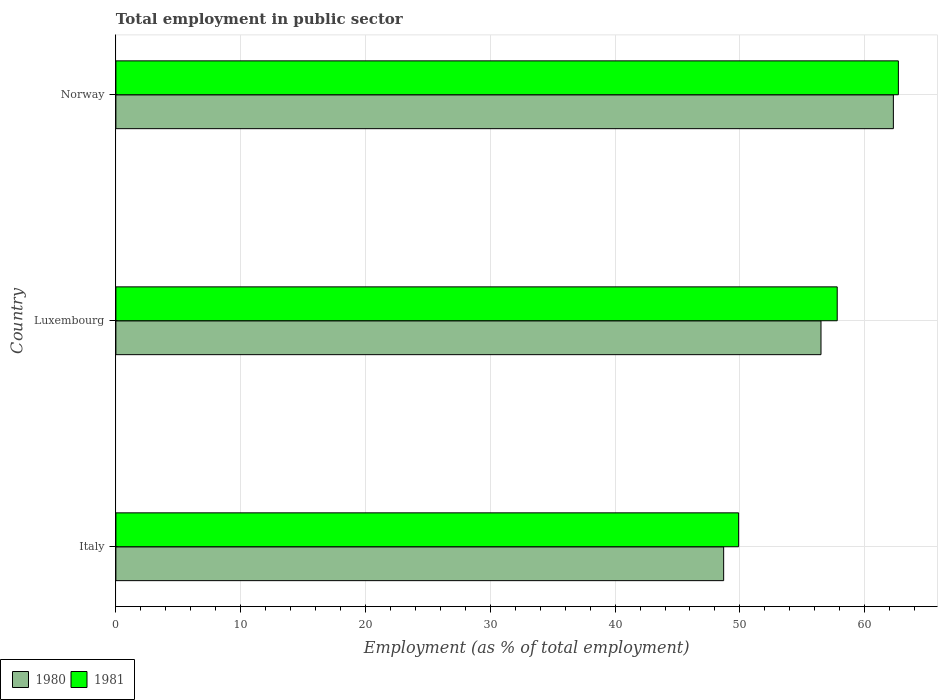Are the number of bars on each tick of the Y-axis equal?
Your answer should be very brief. Yes. How many bars are there on the 3rd tick from the bottom?
Your response must be concise. 2. What is the employment in public sector in 1981 in Luxembourg?
Provide a succinct answer. 57.8. Across all countries, what is the maximum employment in public sector in 1980?
Offer a very short reply. 62.3. Across all countries, what is the minimum employment in public sector in 1980?
Give a very brief answer. 48.7. In which country was the employment in public sector in 1980 minimum?
Give a very brief answer. Italy. What is the total employment in public sector in 1980 in the graph?
Provide a short and direct response. 167.5. What is the difference between the employment in public sector in 1980 in Italy and that in Norway?
Your answer should be compact. -13.6. What is the difference between the employment in public sector in 1981 in Luxembourg and the employment in public sector in 1980 in Italy?
Keep it short and to the point. 9.1. What is the average employment in public sector in 1981 per country?
Your answer should be very brief. 56.8. What is the difference between the employment in public sector in 1981 and employment in public sector in 1980 in Norway?
Keep it short and to the point. 0.4. In how many countries, is the employment in public sector in 1980 greater than 60 %?
Give a very brief answer. 1. What is the ratio of the employment in public sector in 1980 in Luxembourg to that in Norway?
Offer a very short reply. 0.91. Is the employment in public sector in 1981 in Luxembourg less than that in Norway?
Provide a succinct answer. Yes. Is the difference between the employment in public sector in 1981 in Italy and Luxembourg greater than the difference between the employment in public sector in 1980 in Italy and Luxembourg?
Your response must be concise. No. What is the difference between the highest and the second highest employment in public sector in 1980?
Offer a terse response. 5.8. What is the difference between the highest and the lowest employment in public sector in 1981?
Offer a terse response. 12.8. Where does the legend appear in the graph?
Ensure brevity in your answer.  Bottom left. What is the title of the graph?
Ensure brevity in your answer.  Total employment in public sector. Does "1996" appear as one of the legend labels in the graph?
Ensure brevity in your answer.  No. What is the label or title of the X-axis?
Ensure brevity in your answer.  Employment (as % of total employment). What is the Employment (as % of total employment) of 1980 in Italy?
Provide a succinct answer. 48.7. What is the Employment (as % of total employment) in 1981 in Italy?
Offer a terse response. 49.9. What is the Employment (as % of total employment) of 1980 in Luxembourg?
Offer a very short reply. 56.5. What is the Employment (as % of total employment) of 1981 in Luxembourg?
Your answer should be compact. 57.8. What is the Employment (as % of total employment) of 1980 in Norway?
Your answer should be very brief. 62.3. What is the Employment (as % of total employment) in 1981 in Norway?
Make the answer very short. 62.7. Across all countries, what is the maximum Employment (as % of total employment) in 1980?
Keep it short and to the point. 62.3. Across all countries, what is the maximum Employment (as % of total employment) of 1981?
Keep it short and to the point. 62.7. Across all countries, what is the minimum Employment (as % of total employment) of 1980?
Provide a succinct answer. 48.7. Across all countries, what is the minimum Employment (as % of total employment) of 1981?
Offer a very short reply. 49.9. What is the total Employment (as % of total employment) of 1980 in the graph?
Keep it short and to the point. 167.5. What is the total Employment (as % of total employment) of 1981 in the graph?
Keep it short and to the point. 170.4. What is the difference between the Employment (as % of total employment) in 1981 in Italy and that in Luxembourg?
Your answer should be compact. -7.9. What is the difference between the Employment (as % of total employment) of 1980 in Italy and the Employment (as % of total employment) of 1981 in Luxembourg?
Your answer should be compact. -9.1. What is the difference between the Employment (as % of total employment) in 1980 in Italy and the Employment (as % of total employment) in 1981 in Norway?
Your answer should be very brief. -14. What is the average Employment (as % of total employment) in 1980 per country?
Ensure brevity in your answer.  55.83. What is the average Employment (as % of total employment) in 1981 per country?
Keep it short and to the point. 56.8. What is the difference between the Employment (as % of total employment) of 1980 and Employment (as % of total employment) of 1981 in Italy?
Your answer should be compact. -1.2. What is the difference between the Employment (as % of total employment) of 1980 and Employment (as % of total employment) of 1981 in Norway?
Make the answer very short. -0.4. What is the ratio of the Employment (as % of total employment) of 1980 in Italy to that in Luxembourg?
Provide a short and direct response. 0.86. What is the ratio of the Employment (as % of total employment) in 1981 in Italy to that in Luxembourg?
Your response must be concise. 0.86. What is the ratio of the Employment (as % of total employment) of 1980 in Italy to that in Norway?
Offer a very short reply. 0.78. What is the ratio of the Employment (as % of total employment) of 1981 in Italy to that in Norway?
Keep it short and to the point. 0.8. What is the ratio of the Employment (as % of total employment) in 1980 in Luxembourg to that in Norway?
Your answer should be compact. 0.91. What is the ratio of the Employment (as % of total employment) of 1981 in Luxembourg to that in Norway?
Keep it short and to the point. 0.92. What is the difference between the highest and the second highest Employment (as % of total employment) of 1981?
Your answer should be compact. 4.9. What is the difference between the highest and the lowest Employment (as % of total employment) in 1980?
Your answer should be very brief. 13.6. What is the difference between the highest and the lowest Employment (as % of total employment) in 1981?
Offer a terse response. 12.8. 